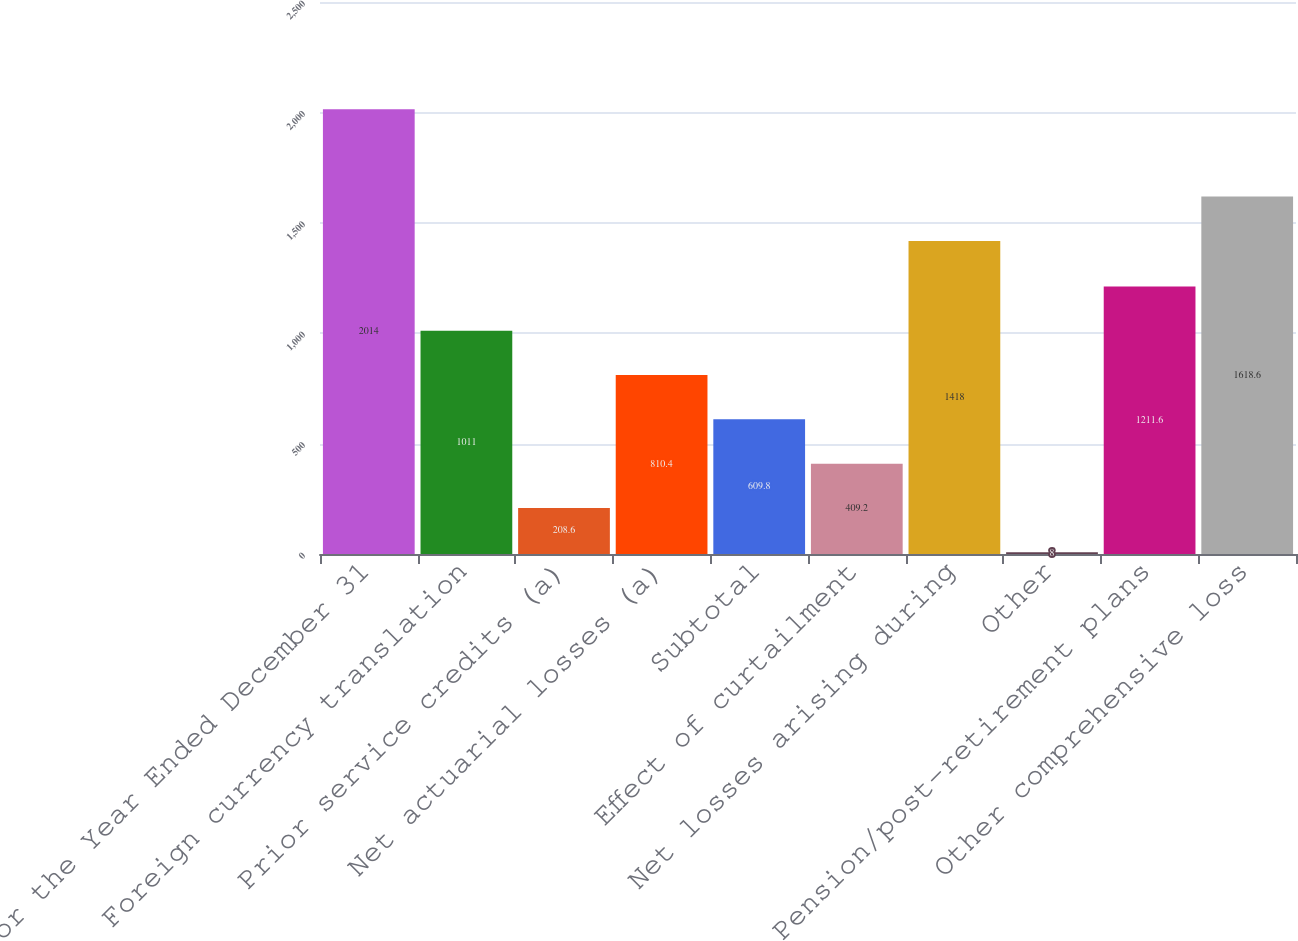<chart> <loc_0><loc_0><loc_500><loc_500><bar_chart><fcel>For the Year Ended December 31<fcel>Foreign currency translation<fcel>Prior service credits (a)<fcel>Net actuarial losses (a)<fcel>Subtotal<fcel>Effect of curtailment<fcel>Net losses arising during<fcel>Other<fcel>Pension/post-retirement plans<fcel>Other comprehensive loss<nl><fcel>2014<fcel>1011<fcel>208.6<fcel>810.4<fcel>609.8<fcel>409.2<fcel>1418<fcel>8<fcel>1211.6<fcel>1618.6<nl></chart> 